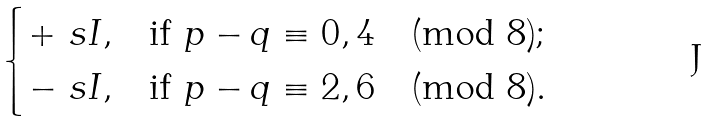Convert formula to latex. <formula><loc_0><loc_0><loc_500><loc_500>\begin{cases} + \ s I , & \text {if $p-q\equiv 0,4\pmod{8}$} ; \\ - \ s I , & \text {if $p-q\equiv 2,6\pmod{8}$} . \end{cases}</formula> 